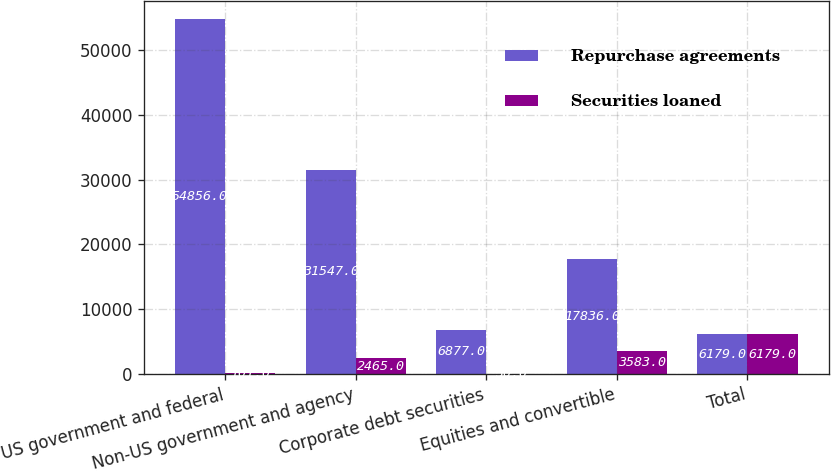Convert chart. <chart><loc_0><loc_0><loc_500><loc_500><stacked_bar_chart><ecel><fcel>US government and federal<fcel>Non-US government and agency<fcel>Corporate debt securities<fcel>Equities and convertible<fcel>Total<nl><fcel>Repurchase agreements<fcel>54856<fcel>31547<fcel>6877<fcel>17836<fcel>6179<nl><fcel>Securities loaned<fcel>101<fcel>2465<fcel>30<fcel>3583<fcel>6179<nl></chart> 